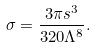Convert formula to latex. <formula><loc_0><loc_0><loc_500><loc_500>\sigma = \frac { 3 \pi s ^ { 3 } } { 3 2 0 \Lambda ^ { 8 } } .</formula> 